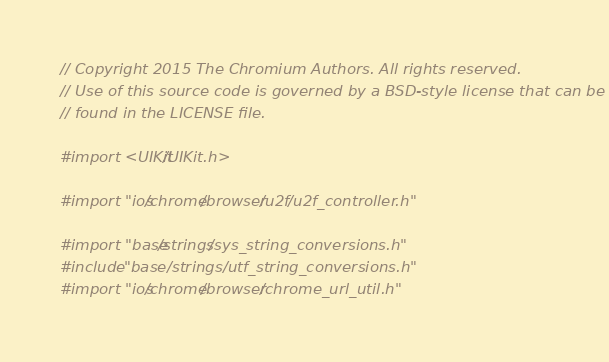<code> <loc_0><loc_0><loc_500><loc_500><_ObjectiveC_>// Copyright 2015 The Chromium Authors. All rights reserved.
// Use of this source code is governed by a BSD-style license that can be
// found in the LICENSE file.

#import <UIKit/UIKit.h>

#import "ios/chrome/browser/u2f/u2f_controller.h"

#import "base/strings/sys_string_conversions.h"
#include "base/strings/utf_string_conversions.h"
#import "ios/chrome/browser/chrome_url_util.h"</code> 